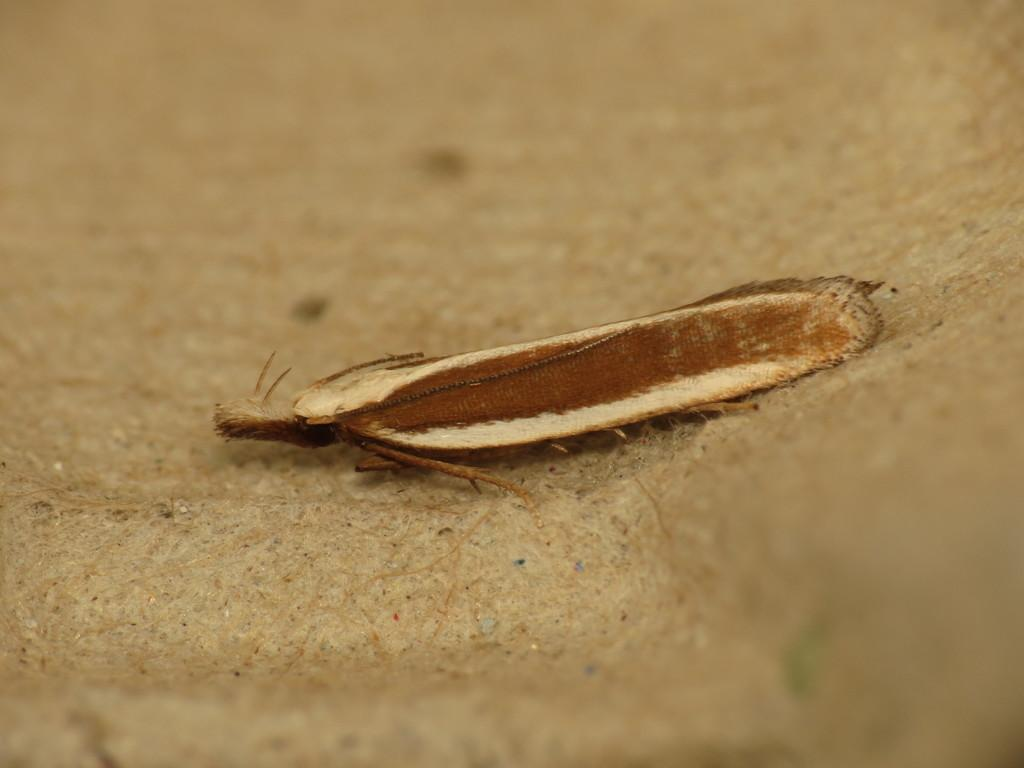What type of creature can be seen in the image? There is an insect in the image. Where is the insect located in the image? The insect is on the ground. What type of apparatus is being used for breakfast in the image? There is no apparatus or reference to breakfast present in the image; it only features an insect on the ground. 